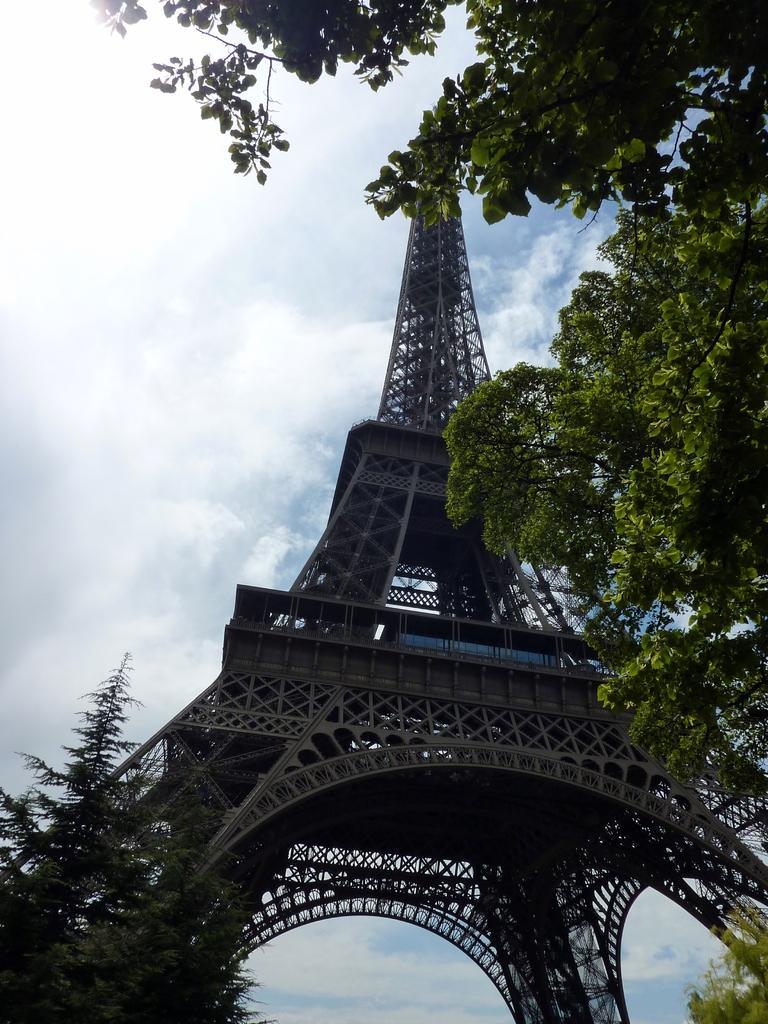Can you describe this image briefly? In this image we can see Eiffel tower. Also there are branches of trees. In the background there is sky with clouds. 